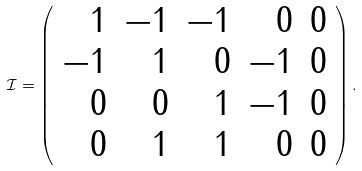Convert formula to latex. <formula><loc_0><loc_0><loc_500><loc_500>\mathcal { I } = \left ( \begin{array} { r r r r r } 1 & - 1 & - 1 & 0 & 0 \\ - 1 & 1 & 0 & - 1 & 0 \\ 0 & 0 & 1 & - 1 & 0 \\ 0 & 1 & 1 & 0 & 0 \end{array} \right ) .</formula> 